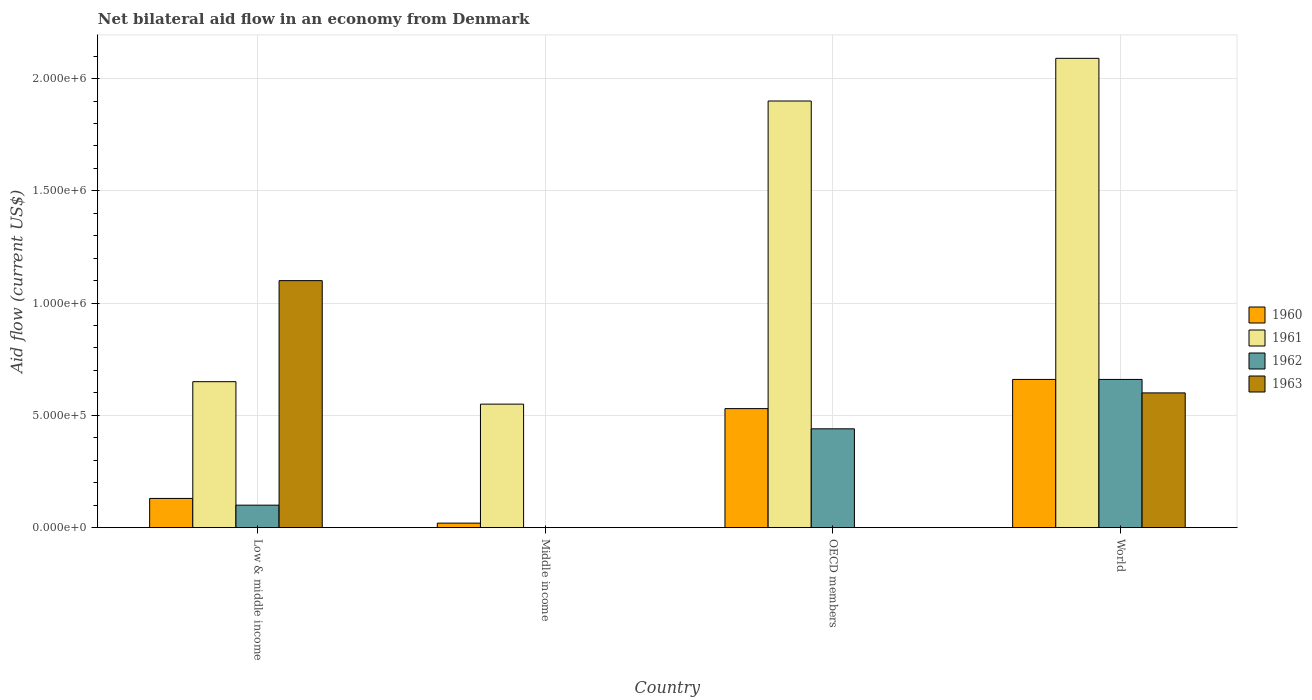How many different coloured bars are there?
Your answer should be very brief. 4. How many groups of bars are there?
Offer a terse response. 4. How many bars are there on the 4th tick from the right?
Give a very brief answer. 4. What is the net bilateral aid flow in 1963 in Low & middle income?
Provide a succinct answer. 1.10e+06. Across all countries, what is the maximum net bilateral aid flow in 1960?
Ensure brevity in your answer.  6.60e+05. Across all countries, what is the minimum net bilateral aid flow in 1960?
Give a very brief answer. 2.00e+04. In which country was the net bilateral aid flow in 1960 maximum?
Keep it short and to the point. World. What is the total net bilateral aid flow in 1961 in the graph?
Your response must be concise. 5.19e+06. What is the difference between the net bilateral aid flow in 1961 in Middle income and that in World?
Give a very brief answer. -1.54e+06. What is the difference between the net bilateral aid flow in 1961 in OECD members and the net bilateral aid flow in 1962 in World?
Ensure brevity in your answer.  1.24e+06. What is the average net bilateral aid flow in 1961 per country?
Make the answer very short. 1.30e+06. What is the difference between the net bilateral aid flow of/in 1961 and net bilateral aid flow of/in 1962 in World?
Give a very brief answer. 1.43e+06. In how many countries, is the net bilateral aid flow in 1962 greater than 1700000 US$?
Your answer should be very brief. 0. What is the ratio of the net bilateral aid flow in 1961 in Middle income to that in World?
Your answer should be very brief. 0.26. Is the difference between the net bilateral aid flow in 1961 in OECD members and World greater than the difference between the net bilateral aid flow in 1962 in OECD members and World?
Make the answer very short. Yes. What is the difference between the highest and the second highest net bilateral aid flow in 1962?
Keep it short and to the point. 5.60e+05. Is the sum of the net bilateral aid flow in 1960 in Low & middle income and World greater than the maximum net bilateral aid flow in 1961 across all countries?
Your answer should be very brief. No. How many bars are there?
Give a very brief answer. 13. Are all the bars in the graph horizontal?
Your answer should be very brief. No. How many countries are there in the graph?
Give a very brief answer. 4. How many legend labels are there?
Give a very brief answer. 4. How are the legend labels stacked?
Ensure brevity in your answer.  Vertical. What is the title of the graph?
Your answer should be very brief. Net bilateral aid flow in an economy from Denmark. What is the Aid flow (current US$) of 1961 in Low & middle income?
Make the answer very short. 6.50e+05. What is the Aid flow (current US$) of 1963 in Low & middle income?
Keep it short and to the point. 1.10e+06. What is the Aid flow (current US$) in 1960 in Middle income?
Make the answer very short. 2.00e+04. What is the Aid flow (current US$) of 1961 in Middle income?
Give a very brief answer. 5.50e+05. What is the Aid flow (current US$) in 1960 in OECD members?
Your response must be concise. 5.30e+05. What is the Aid flow (current US$) in 1961 in OECD members?
Offer a very short reply. 1.90e+06. What is the Aid flow (current US$) in 1962 in OECD members?
Ensure brevity in your answer.  4.40e+05. What is the Aid flow (current US$) of 1961 in World?
Keep it short and to the point. 2.09e+06. What is the Aid flow (current US$) in 1962 in World?
Provide a succinct answer. 6.60e+05. Across all countries, what is the maximum Aid flow (current US$) of 1961?
Make the answer very short. 2.09e+06. Across all countries, what is the maximum Aid flow (current US$) in 1962?
Your answer should be compact. 6.60e+05. Across all countries, what is the maximum Aid flow (current US$) of 1963?
Offer a terse response. 1.10e+06. Across all countries, what is the minimum Aid flow (current US$) in 1960?
Provide a succinct answer. 2.00e+04. Across all countries, what is the minimum Aid flow (current US$) of 1961?
Keep it short and to the point. 5.50e+05. Across all countries, what is the minimum Aid flow (current US$) of 1962?
Keep it short and to the point. 0. Across all countries, what is the minimum Aid flow (current US$) of 1963?
Keep it short and to the point. 0. What is the total Aid flow (current US$) in 1960 in the graph?
Ensure brevity in your answer.  1.34e+06. What is the total Aid flow (current US$) of 1961 in the graph?
Keep it short and to the point. 5.19e+06. What is the total Aid flow (current US$) in 1962 in the graph?
Make the answer very short. 1.20e+06. What is the total Aid flow (current US$) of 1963 in the graph?
Your answer should be very brief. 1.70e+06. What is the difference between the Aid flow (current US$) of 1960 in Low & middle income and that in Middle income?
Your response must be concise. 1.10e+05. What is the difference between the Aid flow (current US$) of 1961 in Low & middle income and that in Middle income?
Provide a succinct answer. 1.00e+05. What is the difference between the Aid flow (current US$) of 1960 in Low & middle income and that in OECD members?
Provide a short and direct response. -4.00e+05. What is the difference between the Aid flow (current US$) in 1961 in Low & middle income and that in OECD members?
Give a very brief answer. -1.25e+06. What is the difference between the Aid flow (current US$) in 1962 in Low & middle income and that in OECD members?
Offer a terse response. -3.40e+05. What is the difference between the Aid flow (current US$) in 1960 in Low & middle income and that in World?
Your answer should be compact. -5.30e+05. What is the difference between the Aid flow (current US$) in 1961 in Low & middle income and that in World?
Keep it short and to the point. -1.44e+06. What is the difference between the Aid flow (current US$) of 1962 in Low & middle income and that in World?
Make the answer very short. -5.60e+05. What is the difference between the Aid flow (current US$) in 1960 in Middle income and that in OECD members?
Your response must be concise. -5.10e+05. What is the difference between the Aid flow (current US$) in 1961 in Middle income and that in OECD members?
Your answer should be compact. -1.35e+06. What is the difference between the Aid flow (current US$) in 1960 in Middle income and that in World?
Provide a short and direct response. -6.40e+05. What is the difference between the Aid flow (current US$) of 1961 in Middle income and that in World?
Keep it short and to the point. -1.54e+06. What is the difference between the Aid flow (current US$) of 1960 in OECD members and that in World?
Give a very brief answer. -1.30e+05. What is the difference between the Aid flow (current US$) in 1962 in OECD members and that in World?
Your response must be concise. -2.20e+05. What is the difference between the Aid flow (current US$) in 1960 in Low & middle income and the Aid flow (current US$) in 1961 in Middle income?
Make the answer very short. -4.20e+05. What is the difference between the Aid flow (current US$) in 1960 in Low & middle income and the Aid flow (current US$) in 1961 in OECD members?
Your response must be concise. -1.77e+06. What is the difference between the Aid flow (current US$) of 1960 in Low & middle income and the Aid flow (current US$) of 1962 in OECD members?
Your response must be concise. -3.10e+05. What is the difference between the Aid flow (current US$) in 1960 in Low & middle income and the Aid flow (current US$) in 1961 in World?
Your response must be concise. -1.96e+06. What is the difference between the Aid flow (current US$) of 1960 in Low & middle income and the Aid flow (current US$) of 1962 in World?
Make the answer very short. -5.30e+05. What is the difference between the Aid flow (current US$) in 1960 in Low & middle income and the Aid flow (current US$) in 1963 in World?
Make the answer very short. -4.70e+05. What is the difference between the Aid flow (current US$) in 1961 in Low & middle income and the Aid flow (current US$) in 1962 in World?
Offer a terse response. -10000. What is the difference between the Aid flow (current US$) in 1962 in Low & middle income and the Aid flow (current US$) in 1963 in World?
Offer a terse response. -5.00e+05. What is the difference between the Aid flow (current US$) in 1960 in Middle income and the Aid flow (current US$) in 1961 in OECD members?
Your response must be concise. -1.88e+06. What is the difference between the Aid flow (current US$) in 1960 in Middle income and the Aid flow (current US$) in 1962 in OECD members?
Offer a very short reply. -4.20e+05. What is the difference between the Aid flow (current US$) of 1961 in Middle income and the Aid flow (current US$) of 1962 in OECD members?
Your answer should be very brief. 1.10e+05. What is the difference between the Aid flow (current US$) in 1960 in Middle income and the Aid flow (current US$) in 1961 in World?
Your response must be concise. -2.07e+06. What is the difference between the Aid flow (current US$) of 1960 in Middle income and the Aid flow (current US$) of 1962 in World?
Give a very brief answer. -6.40e+05. What is the difference between the Aid flow (current US$) in 1960 in Middle income and the Aid flow (current US$) in 1963 in World?
Ensure brevity in your answer.  -5.80e+05. What is the difference between the Aid flow (current US$) of 1961 in Middle income and the Aid flow (current US$) of 1962 in World?
Make the answer very short. -1.10e+05. What is the difference between the Aid flow (current US$) in 1961 in Middle income and the Aid flow (current US$) in 1963 in World?
Provide a short and direct response. -5.00e+04. What is the difference between the Aid flow (current US$) of 1960 in OECD members and the Aid flow (current US$) of 1961 in World?
Give a very brief answer. -1.56e+06. What is the difference between the Aid flow (current US$) in 1960 in OECD members and the Aid flow (current US$) in 1962 in World?
Ensure brevity in your answer.  -1.30e+05. What is the difference between the Aid flow (current US$) of 1960 in OECD members and the Aid flow (current US$) of 1963 in World?
Ensure brevity in your answer.  -7.00e+04. What is the difference between the Aid flow (current US$) of 1961 in OECD members and the Aid flow (current US$) of 1962 in World?
Your answer should be compact. 1.24e+06. What is the difference between the Aid flow (current US$) of 1961 in OECD members and the Aid flow (current US$) of 1963 in World?
Your answer should be compact. 1.30e+06. What is the average Aid flow (current US$) in 1960 per country?
Provide a short and direct response. 3.35e+05. What is the average Aid flow (current US$) in 1961 per country?
Provide a short and direct response. 1.30e+06. What is the average Aid flow (current US$) in 1963 per country?
Your answer should be compact. 4.25e+05. What is the difference between the Aid flow (current US$) of 1960 and Aid flow (current US$) of 1961 in Low & middle income?
Your answer should be compact. -5.20e+05. What is the difference between the Aid flow (current US$) of 1960 and Aid flow (current US$) of 1962 in Low & middle income?
Your answer should be compact. 3.00e+04. What is the difference between the Aid flow (current US$) of 1960 and Aid flow (current US$) of 1963 in Low & middle income?
Ensure brevity in your answer.  -9.70e+05. What is the difference between the Aid flow (current US$) of 1961 and Aid flow (current US$) of 1963 in Low & middle income?
Provide a succinct answer. -4.50e+05. What is the difference between the Aid flow (current US$) of 1962 and Aid flow (current US$) of 1963 in Low & middle income?
Your answer should be compact. -1.00e+06. What is the difference between the Aid flow (current US$) of 1960 and Aid flow (current US$) of 1961 in Middle income?
Give a very brief answer. -5.30e+05. What is the difference between the Aid flow (current US$) of 1960 and Aid flow (current US$) of 1961 in OECD members?
Ensure brevity in your answer.  -1.37e+06. What is the difference between the Aid flow (current US$) in 1960 and Aid flow (current US$) in 1962 in OECD members?
Ensure brevity in your answer.  9.00e+04. What is the difference between the Aid flow (current US$) of 1961 and Aid flow (current US$) of 1962 in OECD members?
Your response must be concise. 1.46e+06. What is the difference between the Aid flow (current US$) of 1960 and Aid flow (current US$) of 1961 in World?
Your answer should be very brief. -1.43e+06. What is the difference between the Aid flow (current US$) in 1961 and Aid flow (current US$) in 1962 in World?
Your answer should be very brief. 1.43e+06. What is the difference between the Aid flow (current US$) of 1961 and Aid flow (current US$) of 1963 in World?
Your answer should be compact. 1.49e+06. What is the difference between the Aid flow (current US$) of 1962 and Aid flow (current US$) of 1963 in World?
Offer a terse response. 6.00e+04. What is the ratio of the Aid flow (current US$) in 1961 in Low & middle income to that in Middle income?
Your response must be concise. 1.18. What is the ratio of the Aid flow (current US$) in 1960 in Low & middle income to that in OECD members?
Make the answer very short. 0.25. What is the ratio of the Aid flow (current US$) of 1961 in Low & middle income to that in OECD members?
Your answer should be very brief. 0.34. What is the ratio of the Aid flow (current US$) of 1962 in Low & middle income to that in OECD members?
Make the answer very short. 0.23. What is the ratio of the Aid flow (current US$) of 1960 in Low & middle income to that in World?
Your answer should be very brief. 0.2. What is the ratio of the Aid flow (current US$) in 1961 in Low & middle income to that in World?
Keep it short and to the point. 0.31. What is the ratio of the Aid flow (current US$) in 1962 in Low & middle income to that in World?
Your response must be concise. 0.15. What is the ratio of the Aid flow (current US$) in 1963 in Low & middle income to that in World?
Your response must be concise. 1.83. What is the ratio of the Aid flow (current US$) in 1960 in Middle income to that in OECD members?
Keep it short and to the point. 0.04. What is the ratio of the Aid flow (current US$) of 1961 in Middle income to that in OECD members?
Keep it short and to the point. 0.29. What is the ratio of the Aid flow (current US$) in 1960 in Middle income to that in World?
Provide a short and direct response. 0.03. What is the ratio of the Aid flow (current US$) in 1961 in Middle income to that in World?
Provide a succinct answer. 0.26. What is the ratio of the Aid flow (current US$) in 1960 in OECD members to that in World?
Your answer should be very brief. 0.8. What is the ratio of the Aid flow (current US$) of 1961 in OECD members to that in World?
Your answer should be very brief. 0.91. What is the difference between the highest and the lowest Aid flow (current US$) of 1960?
Offer a terse response. 6.40e+05. What is the difference between the highest and the lowest Aid flow (current US$) of 1961?
Offer a very short reply. 1.54e+06. What is the difference between the highest and the lowest Aid flow (current US$) in 1962?
Ensure brevity in your answer.  6.60e+05. What is the difference between the highest and the lowest Aid flow (current US$) of 1963?
Provide a short and direct response. 1.10e+06. 